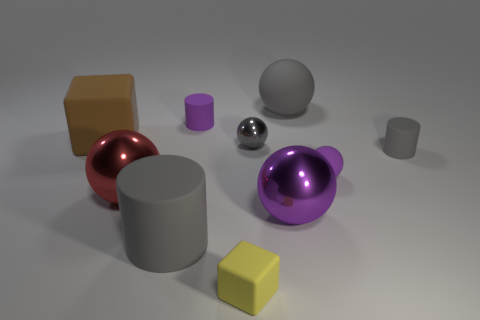What shape is the large matte thing that is the same color as the big rubber ball?
Provide a succinct answer. Cylinder. Is the purple cylinder made of the same material as the gray cylinder that is on the left side of the purple cylinder?
Provide a succinct answer. Yes. There is a matte ball that is the same size as the red metallic thing; what color is it?
Make the answer very short. Gray. There is a gray matte cylinder that is on the right side of the yellow object that is in front of the red metallic thing; how big is it?
Keep it short and to the point. Small. There is a large cylinder; does it have the same color as the tiny cylinder that is to the right of the small yellow object?
Make the answer very short. Yes. Are there fewer matte things that are behind the small shiny thing than large gray metal things?
Offer a very short reply. No. How many other things are there of the same size as the brown matte object?
Your answer should be very brief. 4. There is a tiny object in front of the large red metal object; is it the same shape as the brown rubber object?
Offer a terse response. Yes. Are there more large metallic spheres that are in front of the red shiny object than big yellow shiny objects?
Your response must be concise. Yes. The big thing that is both in front of the tiny gray cylinder and to the right of the yellow object is made of what material?
Your response must be concise. Metal. 